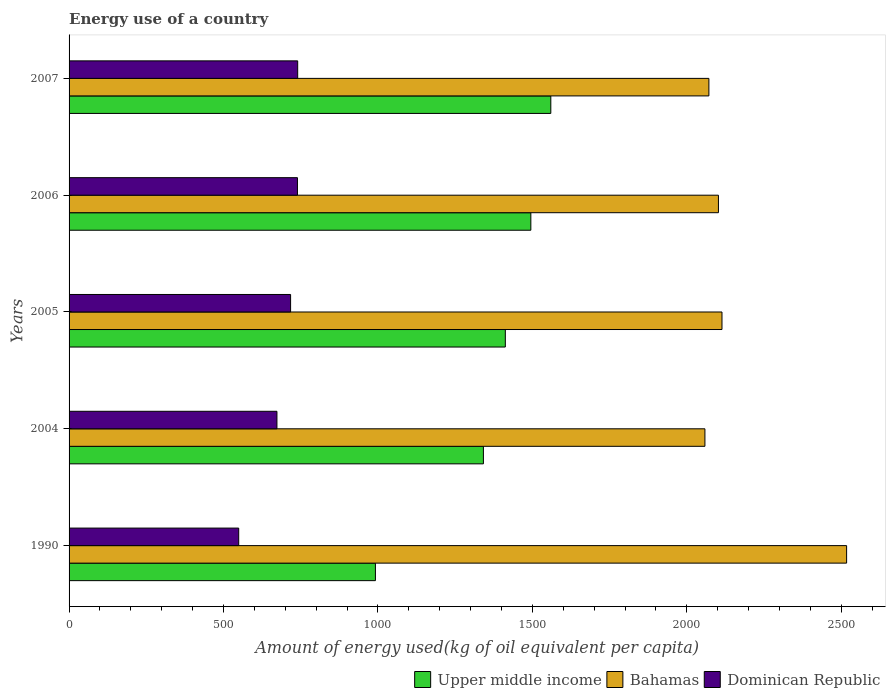How many different coloured bars are there?
Give a very brief answer. 3. Are the number of bars per tick equal to the number of legend labels?
Offer a very short reply. Yes. Are the number of bars on each tick of the Y-axis equal?
Your answer should be compact. Yes. How many bars are there on the 3rd tick from the top?
Offer a terse response. 3. In how many cases, is the number of bars for a given year not equal to the number of legend labels?
Make the answer very short. 0. What is the amount of energy used in in Bahamas in 1990?
Give a very brief answer. 2517.45. Across all years, what is the maximum amount of energy used in in Upper middle income?
Make the answer very short. 1559.74. Across all years, what is the minimum amount of energy used in in Bahamas?
Provide a short and direct response. 2058.67. In which year was the amount of energy used in in Bahamas minimum?
Provide a succinct answer. 2004. What is the total amount of energy used in in Bahamas in the graph?
Make the answer very short. 1.09e+04. What is the difference between the amount of energy used in in Upper middle income in 2006 and that in 2007?
Your answer should be compact. -64.68. What is the difference between the amount of energy used in in Bahamas in 2004 and the amount of energy used in in Upper middle income in 2006?
Offer a very short reply. 563.61. What is the average amount of energy used in in Upper middle income per year?
Your response must be concise. 1360.13. In the year 2005, what is the difference between the amount of energy used in in Bahamas and amount of energy used in in Upper middle income?
Give a very brief answer. 701.46. In how many years, is the amount of energy used in in Upper middle income greater than 1100 kg?
Offer a very short reply. 4. What is the ratio of the amount of energy used in in Upper middle income in 2006 to that in 2007?
Ensure brevity in your answer.  0.96. Is the amount of energy used in in Bahamas in 2004 less than that in 2006?
Your response must be concise. Yes. What is the difference between the highest and the second highest amount of energy used in in Bahamas?
Offer a very short reply. 403.51. What is the difference between the highest and the lowest amount of energy used in in Bahamas?
Make the answer very short. 458.78. In how many years, is the amount of energy used in in Bahamas greater than the average amount of energy used in in Bahamas taken over all years?
Provide a short and direct response. 1. What does the 2nd bar from the top in 2004 represents?
Your response must be concise. Bahamas. What does the 3rd bar from the bottom in 1990 represents?
Offer a very short reply. Dominican Republic. Is it the case that in every year, the sum of the amount of energy used in in Bahamas and amount of energy used in in Upper middle income is greater than the amount of energy used in in Dominican Republic?
Offer a very short reply. Yes. How many years are there in the graph?
Your answer should be very brief. 5. What is the difference between two consecutive major ticks on the X-axis?
Provide a succinct answer. 500. Does the graph contain grids?
Give a very brief answer. No. How are the legend labels stacked?
Provide a short and direct response. Horizontal. What is the title of the graph?
Offer a very short reply. Energy use of a country. Does "Sri Lanka" appear as one of the legend labels in the graph?
Provide a succinct answer. No. What is the label or title of the X-axis?
Offer a terse response. Amount of energy used(kg of oil equivalent per capita). What is the Amount of energy used(kg of oil equivalent per capita) in Upper middle income in 1990?
Your response must be concise. 991.86. What is the Amount of energy used(kg of oil equivalent per capita) in Bahamas in 1990?
Ensure brevity in your answer.  2517.45. What is the Amount of energy used(kg of oil equivalent per capita) in Dominican Republic in 1990?
Your answer should be very brief. 549.2. What is the Amount of energy used(kg of oil equivalent per capita) in Upper middle income in 2004?
Offer a terse response. 1341.51. What is the Amount of energy used(kg of oil equivalent per capita) in Bahamas in 2004?
Give a very brief answer. 2058.67. What is the Amount of energy used(kg of oil equivalent per capita) in Dominican Republic in 2004?
Keep it short and to the point. 673.01. What is the Amount of energy used(kg of oil equivalent per capita) of Upper middle income in 2005?
Keep it short and to the point. 1412.48. What is the Amount of energy used(kg of oil equivalent per capita) of Bahamas in 2005?
Offer a terse response. 2113.94. What is the Amount of energy used(kg of oil equivalent per capita) of Dominican Republic in 2005?
Provide a short and direct response. 717.24. What is the Amount of energy used(kg of oil equivalent per capita) in Upper middle income in 2006?
Your answer should be compact. 1495.06. What is the Amount of energy used(kg of oil equivalent per capita) in Bahamas in 2006?
Keep it short and to the point. 2102.44. What is the Amount of energy used(kg of oil equivalent per capita) of Dominican Republic in 2006?
Keep it short and to the point. 739.43. What is the Amount of energy used(kg of oil equivalent per capita) of Upper middle income in 2007?
Provide a succinct answer. 1559.74. What is the Amount of energy used(kg of oil equivalent per capita) of Bahamas in 2007?
Offer a terse response. 2071.53. What is the Amount of energy used(kg of oil equivalent per capita) in Dominican Republic in 2007?
Your answer should be very brief. 740.18. Across all years, what is the maximum Amount of energy used(kg of oil equivalent per capita) of Upper middle income?
Give a very brief answer. 1559.74. Across all years, what is the maximum Amount of energy used(kg of oil equivalent per capita) in Bahamas?
Your response must be concise. 2517.45. Across all years, what is the maximum Amount of energy used(kg of oil equivalent per capita) in Dominican Republic?
Give a very brief answer. 740.18. Across all years, what is the minimum Amount of energy used(kg of oil equivalent per capita) in Upper middle income?
Your answer should be very brief. 991.86. Across all years, what is the minimum Amount of energy used(kg of oil equivalent per capita) in Bahamas?
Offer a terse response. 2058.67. Across all years, what is the minimum Amount of energy used(kg of oil equivalent per capita) in Dominican Republic?
Provide a short and direct response. 549.2. What is the total Amount of energy used(kg of oil equivalent per capita) in Upper middle income in the graph?
Make the answer very short. 6800.65. What is the total Amount of energy used(kg of oil equivalent per capita) of Bahamas in the graph?
Provide a succinct answer. 1.09e+04. What is the total Amount of energy used(kg of oil equivalent per capita) in Dominican Republic in the graph?
Your answer should be compact. 3419.06. What is the difference between the Amount of energy used(kg of oil equivalent per capita) of Upper middle income in 1990 and that in 2004?
Give a very brief answer. -349.64. What is the difference between the Amount of energy used(kg of oil equivalent per capita) of Bahamas in 1990 and that in 2004?
Your answer should be compact. 458.78. What is the difference between the Amount of energy used(kg of oil equivalent per capita) in Dominican Republic in 1990 and that in 2004?
Your answer should be compact. -123.81. What is the difference between the Amount of energy used(kg of oil equivalent per capita) of Upper middle income in 1990 and that in 2005?
Your answer should be very brief. -420.61. What is the difference between the Amount of energy used(kg of oil equivalent per capita) in Bahamas in 1990 and that in 2005?
Your answer should be compact. 403.51. What is the difference between the Amount of energy used(kg of oil equivalent per capita) in Dominican Republic in 1990 and that in 2005?
Provide a succinct answer. -168.04. What is the difference between the Amount of energy used(kg of oil equivalent per capita) of Upper middle income in 1990 and that in 2006?
Provide a succinct answer. -503.2. What is the difference between the Amount of energy used(kg of oil equivalent per capita) of Bahamas in 1990 and that in 2006?
Offer a terse response. 415.01. What is the difference between the Amount of energy used(kg of oil equivalent per capita) in Dominican Republic in 1990 and that in 2006?
Ensure brevity in your answer.  -190.23. What is the difference between the Amount of energy used(kg of oil equivalent per capita) of Upper middle income in 1990 and that in 2007?
Give a very brief answer. -567.88. What is the difference between the Amount of energy used(kg of oil equivalent per capita) in Bahamas in 1990 and that in 2007?
Your answer should be compact. 445.92. What is the difference between the Amount of energy used(kg of oil equivalent per capita) in Dominican Republic in 1990 and that in 2007?
Ensure brevity in your answer.  -190.98. What is the difference between the Amount of energy used(kg of oil equivalent per capita) in Upper middle income in 2004 and that in 2005?
Ensure brevity in your answer.  -70.97. What is the difference between the Amount of energy used(kg of oil equivalent per capita) in Bahamas in 2004 and that in 2005?
Offer a very short reply. -55.27. What is the difference between the Amount of energy used(kg of oil equivalent per capita) in Dominican Republic in 2004 and that in 2005?
Give a very brief answer. -44.24. What is the difference between the Amount of energy used(kg of oil equivalent per capita) of Upper middle income in 2004 and that in 2006?
Make the answer very short. -153.55. What is the difference between the Amount of energy used(kg of oil equivalent per capita) of Bahamas in 2004 and that in 2006?
Your response must be concise. -43.77. What is the difference between the Amount of energy used(kg of oil equivalent per capita) in Dominican Republic in 2004 and that in 2006?
Make the answer very short. -66.42. What is the difference between the Amount of energy used(kg of oil equivalent per capita) of Upper middle income in 2004 and that in 2007?
Ensure brevity in your answer.  -218.24. What is the difference between the Amount of energy used(kg of oil equivalent per capita) of Bahamas in 2004 and that in 2007?
Your answer should be compact. -12.86. What is the difference between the Amount of energy used(kg of oil equivalent per capita) in Dominican Republic in 2004 and that in 2007?
Offer a very short reply. -67.17. What is the difference between the Amount of energy used(kg of oil equivalent per capita) in Upper middle income in 2005 and that in 2006?
Give a very brief answer. -82.58. What is the difference between the Amount of energy used(kg of oil equivalent per capita) in Bahamas in 2005 and that in 2006?
Make the answer very short. 11.5. What is the difference between the Amount of energy used(kg of oil equivalent per capita) in Dominican Republic in 2005 and that in 2006?
Keep it short and to the point. -22.19. What is the difference between the Amount of energy used(kg of oil equivalent per capita) of Upper middle income in 2005 and that in 2007?
Give a very brief answer. -147.27. What is the difference between the Amount of energy used(kg of oil equivalent per capita) of Bahamas in 2005 and that in 2007?
Your answer should be compact. 42.41. What is the difference between the Amount of energy used(kg of oil equivalent per capita) in Dominican Republic in 2005 and that in 2007?
Keep it short and to the point. -22.94. What is the difference between the Amount of energy used(kg of oil equivalent per capita) in Upper middle income in 2006 and that in 2007?
Ensure brevity in your answer.  -64.68. What is the difference between the Amount of energy used(kg of oil equivalent per capita) of Bahamas in 2006 and that in 2007?
Your answer should be very brief. 30.91. What is the difference between the Amount of energy used(kg of oil equivalent per capita) of Dominican Republic in 2006 and that in 2007?
Your answer should be compact. -0.75. What is the difference between the Amount of energy used(kg of oil equivalent per capita) of Upper middle income in 1990 and the Amount of energy used(kg of oil equivalent per capita) of Bahamas in 2004?
Keep it short and to the point. -1066.8. What is the difference between the Amount of energy used(kg of oil equivalent per capita) in Upper middle income in 1990 and the Amount of energy used(kg of oil equivalent per capita) in Dominican Republic in 2004?
Keep it short and to the point. 318.86. What is the difference between the Amount of energy used(kg of oil equivalent per capita) in Bahamas in 1990 and the Amount of energy used(kg of oil equivalent per capita) in Dominican Republic in 2004?
Your answer should be very brief. 1844.44. What is the difference between the Amount of energy used(kg of oil equivalent per capita) in Upper middle income in 1990 and the Amount of energy used(kg of oil equivalent per capita) in Bahamas in 2005?
Ensure brevity in your answer.  -1122.08. What is the difference between the Amount of energy used(kg of oil equivalent per capita) in Upper middle income in 1990 and the Amount of energy used(kg of oil equivalent per capita) in Dominican Republic in 2005?
Offer a terse response. 274.62. What is the difference between the Amount of energy used(kg of oil equivalent per capita) in Bahamas in 1990 and the Amount of energy used(kg of oil equivalent per capita) in Dominican Republic in 2005?
Your response must be concise. 1800.2. What is the difference between the Amount of energy used(kg of oil equivalent per capita) of Upper middle income in 1990 and the Amount of energy used(kg of oil equivalent per capita) of Bahamas in 2006?
Your answer should be compact. -1110.57. What is the difference between the Amount of energy used(kg of oil equivalent per capita) in Upper middle income in 1990 and the Amount of energy used(kg of oil equivalent per capita) in Dominican Republic in 2006?
Ensure brevity in your answer.  252.43. What is the difference between the Amount of energy used(kg of oil equivalent per capita) of Bahamas in 1990 and the Amount of energy used(kg of oil equivalent per capita) of Dominican Republic in 2006?
Keep it short and to the point. 1778.02. What is the difference between the Amount of energy used(kg of oil equivalent per capita) in Upper middle income in 1990 and the Amount of energy used(kg of oil equivalent per capita) in Bahamas in 2007?
Make the answer very short. -1079.67. What is the difference between the Amount of energy used(kg of oil equivalent per capita) in Upper middle income in 1990 and the Amount of energy used(kg of oil equivalent per capita) in Dominican Republic in 2007?
Make the answer very short. 251.69. What is the difference between the Amount of energy used(kg of oil equivalent per capita) of Bahamas in 1990 and the Amount of energy used(kg of oil equivalent per capita) of Dominican Republic in 2007?
Keep it short and to the point. 1777.27. What is the difference between the Amount of energy used(kg of oil equivalent per capita) in Upper middle income in 2004 and the Amount of energy used(kg of oil equivalent per capita) in Bahamas in 2005?
Keep it short and to the point. -772.43. What is the difference between the Amount of energy used(kg of oil equivalent per capita) of Upper middle income in 2004 and the Amount of energy used(kg of oil equivalent per capita) of Dominican Republic in 2005?
Ensure brevity in your answer.  624.26. What is the difference between the Amount of energy used(kg of oil equivalent per capita) of Bahamas in 2004 and the Amount of energy used(kg of oil equivalent per capita) of Dominican Republic in 2005?
Make the answer very short. 1341.42. What is the difference between the Amount of energy used(kg of oil equivalent per capita) in Upper middle income in 2004 and the Amount of energy used(kg of oil equivalent per capita) in Bahamas in 2006?
Offer a terse response. -760.93. What is the difference between the Amount of energy used(kg of oil equivalent per capita) in Upper middle income in 2004 and the Amount of energy used(kg of oil equivalent per capita) in Dominican Republic in 2006?
Offer a terse response. 602.08. What is the difference between the Amount of energy used(kg of oil equivalent per capita) of Bahamas in 2004 and the Amount of energy used(kg of oil equivalent per capita) of Dominican Republic in 2006?
Provide a short and direct response. 1319.24. What is the difference between the Amount of energy used(kg of oil equivalent per capita) in Upper middle income in 2004 and the Amount of energy used(kg of oil equivalent per capita) in Bahamas in 2007?
Make the answer very short. -730.03. What is the difference between the Amount of energy used(kg of oil equivalent per capita) of Upper middle income in 2004 and the Amount of energy used(kg of oil equivalent per capita) of Dominican Republic in 2007?
Ensure brevity in your answer.  601.33. What is the difference between the Amount of energy used(kg of oil equivalent per capita) of Bahamas in 2004 and the Amount of energy used(kg of oil equivalent per capita) of Dominican Republic in 2007?
Offer a very short reply. 1318.49. What is the difference between the Amount of energy used(kg of oil equivalent per capita) of Upper middle income in 2005 and the Amount of energy used(kg of oil equivalent per capita) of Bahamas in 2006?
Provide a short and direct response. -689.96. What is the difference between the Amount of energy used(kg of oil equivalent per capita) of Upper middle income in 2005 and the Amount of energy used(kg of oil equivalent per capita) of Dominican Republic in 2006?
Give a very brief answer. 673.05. What is the difference between the Amount of energy used(kg of oil equivalent per capita) in Bahamas in 2005 and the Amount of energy used(kg of oil equivalent per capita) in Dominican Republic in 2006?
Give a very brief answer. 1374.51. What is the difference between the Amount of energy used(kg of oil equivalent per capita) in Upper middle income in 2005 and the Amount of energy used(kg of oil equivalent per capita) in Bahamas in 2007?
Make the answer very short. -659.05. What is the difference between the Amount of energy used(kg of oil equivalent per capita) of Upper middle income in 2005 and the Amount of energy used(kg of oil equivalent per capita) of Dominican Republic in 2007?
Your response must be concise. 672.3. What is the difference between the Amount of energy used(kg of oil equivalent per capita) of Bahamas in 2005 and the Amount of energy used(kg of oil equivalent per capita) of Dominican Republic in 2007?
Provide a succinct answer. 1373.76. What is the difference between the Amount of energy used(kg of oil equivalent per capita) of Upper middle income in 2006 and the Amount of energy used(kg of oil equivalent per capita) of Bahamas in 2007?
Keep it short and to the point. -576.47. What is the difference between the Amount of energy used(kg of oil equivalent per capita) of Upper middle income in 2006 and the Amount of energy used(kg of oil equivalent per capita) of Dominican Republic in 2007?
Provide a succinct answer. 754.88. What is the difference between the Amount of energy used(kg of oil equivalent per capita) in Bahamas in 2006 and the Amount of energy used(kg of oil equivalent per capita) in Dominican Republic in 2007?
Your answer should be compact. 1362.26. What is the average Amount of energy used(kg of oil equivalent per capita) in Upper middle income per year?
Give a very brief answer. 1360.13. What is the average Amount of energy used(kg of oil equivalent per capita) in Bahamas per year?
Your answer should be very brief. 2172.8. What is the average Amount of energy used(kg of oil equivalent per capita) in Dominican Republic per year?
Your answer should be very brief. 683.81. In the year 1990, what is the difference between the Amount of energy used(kg of oil equivalent per capita) of Upper middle income and Amount of energy used(kg of oil equivalent per capita) of Bahamas?
Make the answer very short. -1525.58. In the year 1990, what is the difference between the Amount of energy used(kg of oil equivalent per capita) in Upper middle income and Amount of energy used(kg of oil equivalent per capita) in Dominican Republic?
Your answer should be compact. 442.67. In the year 1990, what is the difference between the Amount of energy used(kg of oil equivalent per capita) of Bahamas and Amount of energy used(kg of oil equivalent per capita) of Dominican Republic?
Your answer should be very brief. 1968.25. In the year 2004, what is the difference between the Amount of energy used(kg of oil equivalent per capita) of Upper middle income and Amount of energy used(kg of oil equivalent per capita) of Bahamas?
Provide a short and direct response. -717.16. In the year 2004, what is the difference between the Amount of energy used(kg of oil equivalent per capita) of Upper middle income and Amount of energy used(kg of oil equivalent per capita) of Dominican Republic?
Your response must be concise. 668.5. In the year 2004, what is the difference between the Amount of energy used(kg of oil equivalent per capita) in Bahamas and Amount of energy used(kg of oil equivalent per capita) in Dominican Republic?
Give a very brief answer. 1385.66. In the year 2005, what is the difference between the Amount of energy used(kg of oil equivalent per capita) of Upper middle income and Amount of energy used(kg of oil equivalent per capita) of Bahamas?
Give a very brief answer. -701.46. In the year 2005, what is the difference between the Amount of energy used(kg of oil equivalent per capita) in Upper middle income and Amount of energy used(kg of oil equivalent per capita) in Dominican Republic?
Provide a short and direct response. 695.23. In the year 2005, what is the difference between the Amount of energy used(kg of oil equivalent per capita) of Bahamas and Amount of energy used(kg of oil equivalent per capita) of Dominican Republic?
Ensure brevity in your answer.  1396.7. In the year 2006, what is the difference between the Amount of energy used(kg of oil equivalent per capita) in Upper middle income and Amount of energy used(kg of oil equivalent per capita) in Bahamas?
Offer a terse response. -607.38. In the year 2006, what is the difference between the Amount of energy used(kg of oil equivalent per capita) of Upper middle income and Amount of energy used(kg of oil equivalent per capita) of Dominican Republic?
Your answer should be compact. 755.63. In the year 2006, what is the difference between the Amount of energy used(kg of oil equivalent per capita) in Bahamas and Amount of energy used(kg of oil equivalent per capita) in Dominican Republic?
Your answer should be compact. 1363.01. In the year 2007, what is the difference between the Amount of energy used(kg of oil equivalent per capita) in Upper middle income and Amount of energy used(kg of oil equivalent per capita) in Bahamas?
Your answer should be compact. -511.79. In the year 2007, what is the difference between the Amount of energy used(kg of oil equivalent per capita) in Upper middle income and Amount of energy used(kg of oil equivalent per capita) in Dominican Republic?
Your answer should be compact. 819.57. In the year 2007, what is the difference between the Amount of energy used(kg of oil equivalent per capita) in Bahamas and Amount of energy used(kg of oil equivalent per capita) in Dominican Republic?
Keep it short and to the point. 1331.35. What is the ratio of the Amount of energy used(kg of oil equivalent per capita) of Upper middle income in 1990 to that in 2004?
Offer a terse response. 0.74. What is the ratio of the Amount of energy used(kg of oil equivalent per capita) in Bahamas in 1990 to that in 2004?
Offer a very short reply. 1.22. What is the ratio of the Amount of energy used(kg of oil equivalent per capita) of Dominican Republic in 1990 to that in 2004?
Your answer should be very brief. 0.82. What is the ratio of the Amount of energy used(kg of oil equivalent per capita) of Upper middle income in 1990 to that in 2005?
Your response must be concise. 0.7. What is the ratio of the Amount of energy used(kg of oil equivalent per capita) in Bahamas in 1990 to that in 2005?
Ensure brevity in your answer.  1.19. What is the ratio of the Amount of energy used(kg of oil equivalent per capita) in Dominican Republic in 1990 to that in 2005?
Offer a very short reply. 0.77. What is the ratio of the Amount of energy used(kg of oil equivalent per capita) of Upper middle income in 1990 to that in 2006?
Provide a succinct answer. 0.66. What is the ratio of the Amount of energy used(kg of oil equivalent per capita) of Bahamas in 1990 to that in 2006?
Provide a succinct answer. 1.2. What is the ratio of the Amount of energy used(kg of oil equivalent per capita) in Dominican Republic in 1990 to that in 2006?
Provide a succinct answer. 0.74. What is the ratio of the Amount of energy used(kg of oil equivalent per capita) of Upper middle income in 1990 to that in 2007?
Ensure brevity in your answer.  0.64. What is the ratio of the Amount of energy used(kg of oil equivalent per capita) of Bahamas in 1990 to that in 2007?
Keep it short and to the point. 1.22. What is the ratio of the Amount of energy used(kg of oil equivalent per capita) in Dominican Republic in 1990 to that in 2007?
Provide a succinct answer. 0.74. What is the ratio of the Amount of energy used(kg of oil equivalent per capita) in Upper middle income in 2004 to that in 2005?
Provide a succinct answer. 0.95. What is the ratio of the Amount of energy used(kg of oil equivalent per capita) in Bahamas in 2004 to that in 2005?
Make the answer very short. 0.97. What is the ratio of the Amount of energy used(kg of oil equivalent per capita) in Dominican Republic in 2004 to that in 2005?
Provide a succinct answer. 0.94. What is the ratio of the Amount of energy used(kg of oil equivalent per capita) of Upper middle income in 2004 to that in 2006?
Keep it short and to the point. 0.9. What is the ratio of the Amount of energy used(kg of oil equivalent per capita) of Bahamas in 2004 to that in 2006?
Keep it short and to the point. 0.98. What is the ratio of the Amount of energy used(kg of oil equivalent per capita) of Dominican Republic in 2004 to that in 2006?
Provide a succinct answer. 0.91. What is the ratio of the Amount of energy used(kg of oil equivalent per capita) in Upper middle income in 2004 to that in 2007?
Your response must be concise. 0.86. What is the ratio of the Amount of energy used(kg of oil equivalent per capita) of Dominican Republic in 2004 to that in 2007?
Make the answer very short. 0.91. What is the ratio of the Amount of energy used(kg of oil equivalent per capita) in Upper middle income in 2005 to that in 2006?
Your response must be concise. 0.94. What is the ratio of the Amount of energy used(kg of oil equivalent per capita) in Upper middle income in 2005 to that in 2007?
Ensure brevity in your answer.  0.91. What is the ratio of the Amount of energy used(kg of oil equivalent per capita) in Bahamas in 2005 to that in 2007?
Give a very brief answer. 1.02. What is the ratio of the Amount of energy used(kg of oil equivalent per capita) of Upper middle income in 2006 to that in 2007?
Offer a very short reply. 0.96. What is the ratio of the Amount of energy used(kg of oil equivalent per capita) in Bahamas in 2006 to that in 2007?
Keep it short and to the point. 1.01. What is the ratio of the Amount of energy used(kg of oil equivalent per capita) of Dominican Republic in 2006 to that in 2007?
Give a very brief answer. 1. What is the difference between the highest and the second highest Amount of energy used(kg of oil equivalent per capita) in Upper middle income?
Provide a succinct answer. 64.68. What is the difference between the highest and the second highest Amount of energy used(kg of oil equivalent per capita) of Bahamas?
Ensure brevity in your answer.  403.51. What is the difference between the highest and the second highest Amount of energy used(kg of oil equivalent per capita) of Dominican Republic?
Provide a succinct answer. 0.75. What is the difference between the highest and the lowest Amount of energy used(kg of oil equivalent per capita) in Upper middle income?
Make the answer very short. 567.88. What is the difference between the highest and the lowest Amount of energy used(kg of oil equivalent per capita) in Bahamas?
Your response must be concise. 458.78. What is the difference between the highest and the lowest Amount of energy used(kg of oil equivalent per capita) in Dominican Republic?
Provide a short and direct response. 190.98. 